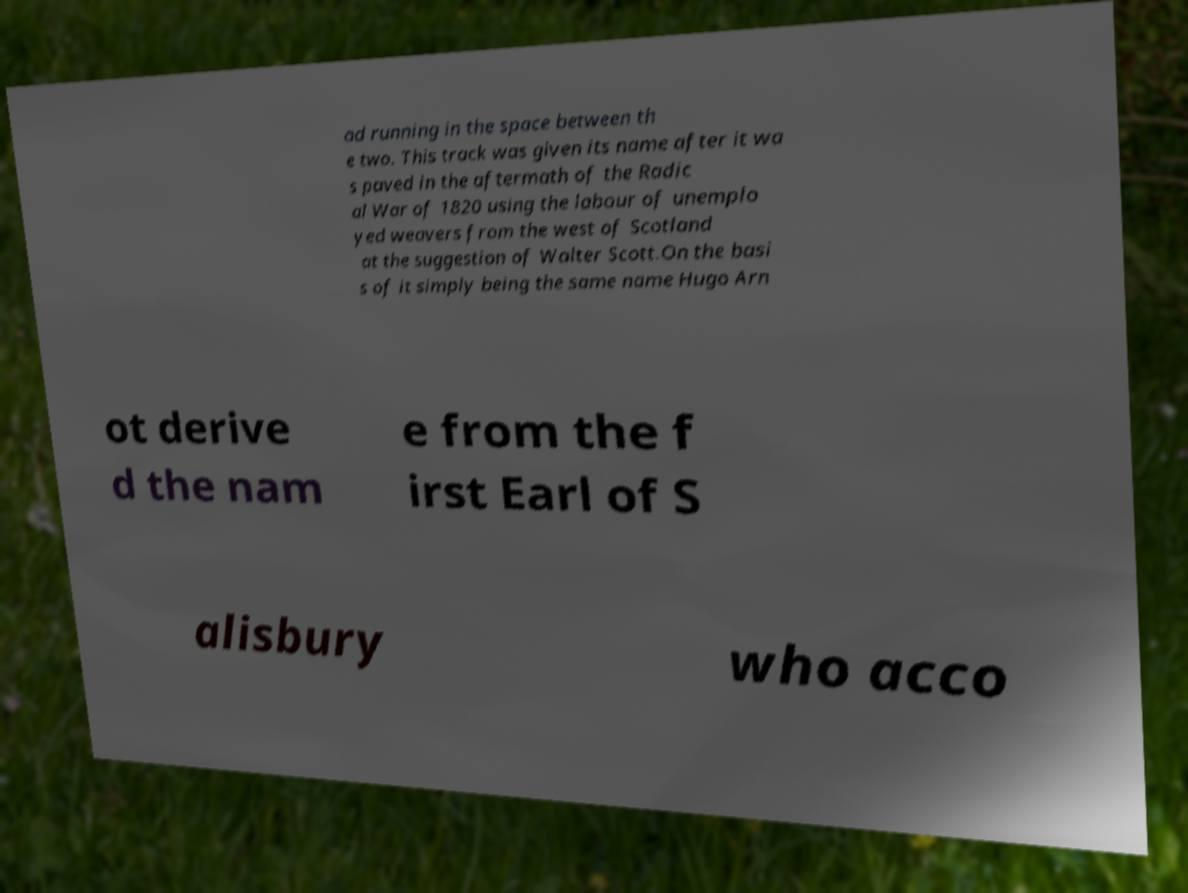What messages or text are displayed in this image? I need them in a readable, typed format. ad running in the space between th e two. This track was given its name after it wa s paved in the aftermath of the Radic al War of 1820 using the labour of unemplo yed weavers from the west of Scotland at the suggestion of Walter Scott.On the basi s of it simply being the same name Hugo Arn ot derive d the nam e from the f irst Earl of S alisbury who acco 